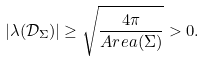<formula> <loc_0><loc_0><loc_500><loc_500>| \lambda ( \mathcal { D } _ { \Sigma } ) | \geq \sqrt { \frac { 4 \pi } { A r e a ( \Sigma ) } } > 0 .</formula> 